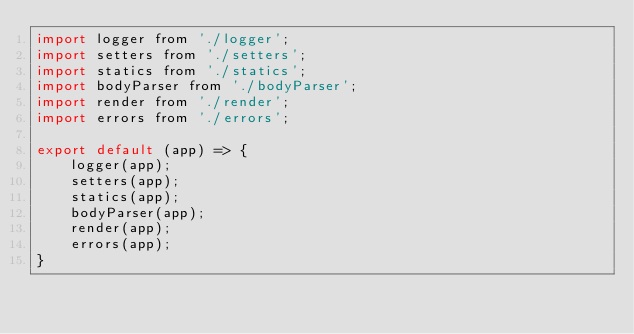<code> <loc_0><loc_0><loc_500><loc_500><_JavaScript_>import logger from './logger';
import setters from './setters';
import statics from './statics';
import bodyParser from './bodyParser';
import render from './render';
import errors from './errors';

export default (app) => {
    logger(app);
    setters(app);
    statics(app);
    bodyParser(app);
    render(app);
    errors(app);
}</code> 